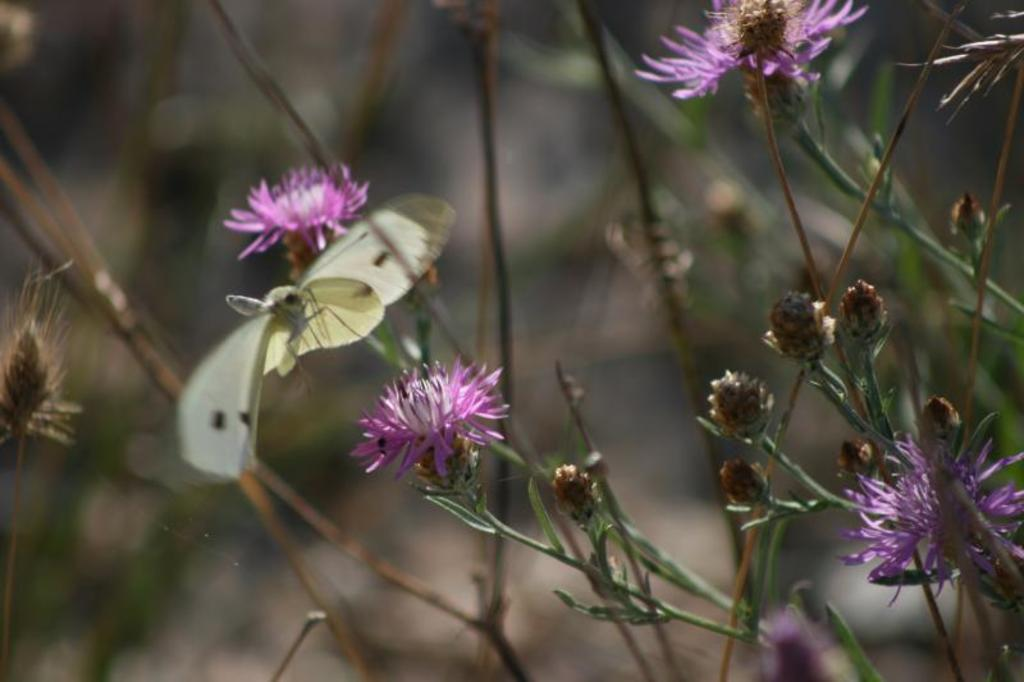What color are the flowers in the image? The flowers in the image are pink. What type of plant is present in the image? There is a plant in the image. Can you describe the background of the image? The background of the image is blurred. How does the plant take flight in the image? The plant does not take flight in the image; it is stationary and rooted in the ground. 